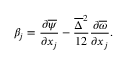<formula> <loc_0><loc_0><loc_500><loc_500>\beta _ { j } = \frac { \partial \overline { \psi } } { \partial x _ { j } } - \frac { \overline { \Delta } ^ { 2 } } { 1 2 } \frac { \partial \overline { \omega } } { \partial x _ { j } } .</formula> 